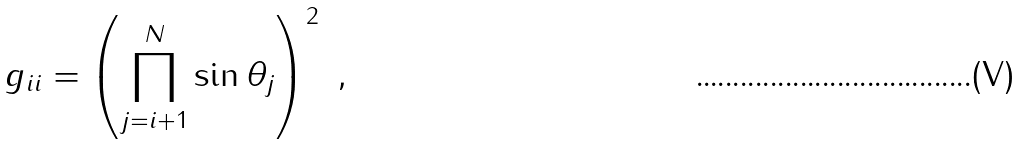<formula> <loc_0><loc_0><loc_500><loc_500>g _ { i i } = \left ( \prod _ { j = i + 1 } ^ { N } \sin \theta _ { j } \right ) ^ { 2 } \ ,</formula> 